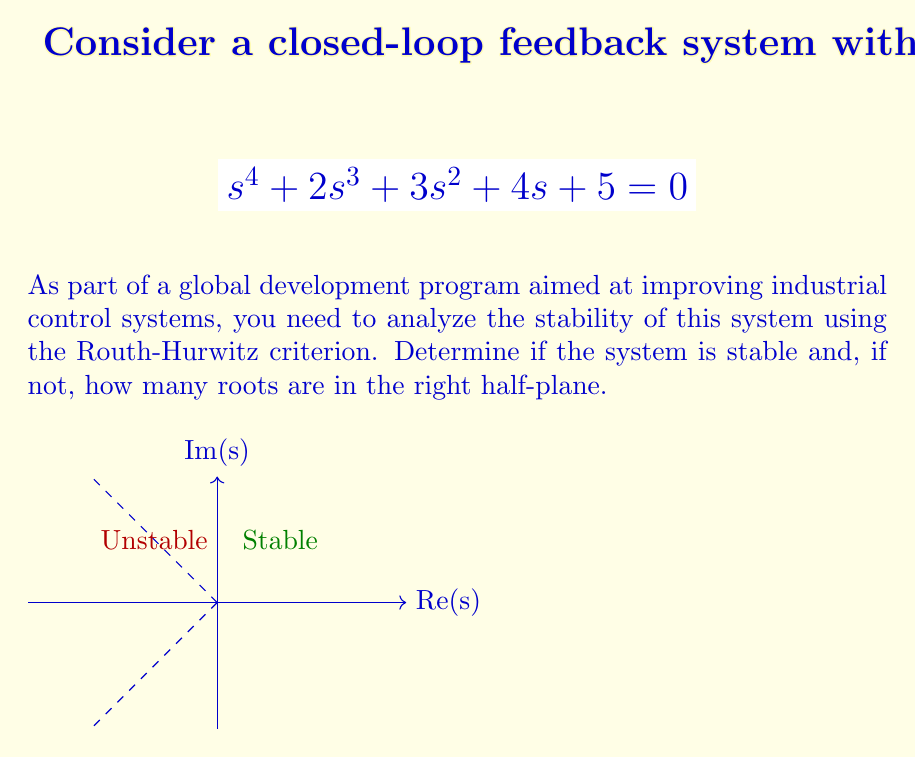Give your solution to this math problem. To analyze the stability using the Routh-Hurwitz criterion, we follow these steps:

1) First, we construct the Routh array:

   $$\begin{array}{c|cccc}
   s^4 & 1 & 3 & 5 \\
   s^3 & 2 & 4 & 0 \\
   s^2 & b_1 & b_2 & \\
   s^1 & c_1 & & \\
   s^0 & d_1 & & 
   \end{array}$$

2) Calculate $b_1$:
   $$b_1 = \frac{(2)(3) - (1)(4)}{2} = \frac{6-4}{2} = 1$$

3) Calculate $b_2$:
   $$b_2 = \frac{(2)(5) - (1)(0)}{2} = \frac{10}{2} = 5$$

4) Calculate $c_1$:
   $$c_1 = \frac{(1)(4) - (2)(5)}{1} = 4 - 10 = -6$$

5) Calculate $d_1$:
   $$d_1 = \frac{(-6)(5) - (1)(0)}{-6} = 5$$

6) The complete Routh array:

   $$\begin{array}{c|cccc}
   s^4 & 1 & 3 & 5 \\
   s^3 & 2 & 4 & 0 \\
   s^2 & 1 & 5 & \\
   s^1 & -6 & & \\
   s^0 & 5 & & 
   \end{array}$$

7) Analyze the first column for sign changes:
   There is one sign change between $s^2$ and $s^1$ rows.

8) According to the Routh-Hurwitz criterion, the number of sign changes in the first column of the Routh array equals the number of roots in the right half-plane.

Therefore, the system is unstable with one root in the right half-plane.
Answer: Unstable; 1 root in right half-plane 